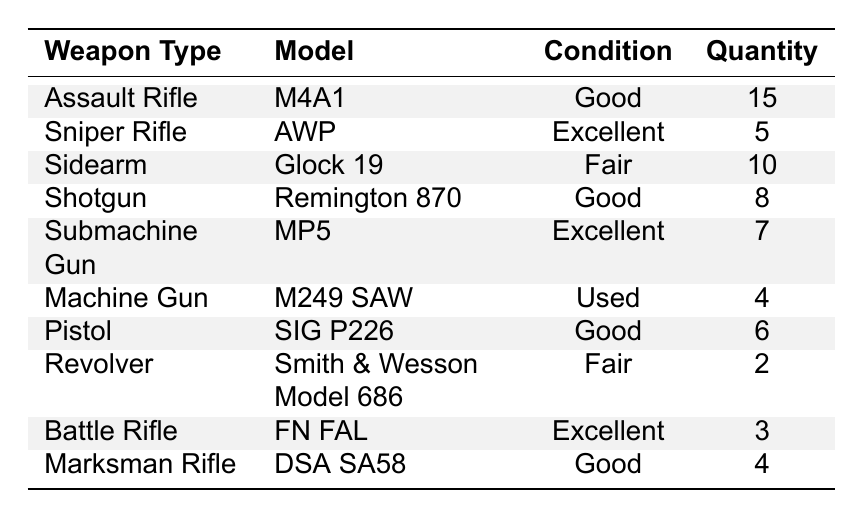What is the total quantity of "Good" condition weapons? To find this, we look at the quantities of weapons listed as "Good": M4A1 (15), Remington 870 (8), SIG P226 (6), and DSA SA58 (4). Summing these values gives us 15 + 8 + 6 + 4 = 33.
Answer: 33 How many types of weapons have an "Excellent" condition? From the table, we see that the weapons listed as "Excellent" are AWP, MP5, and FN FAL. Counting these gives us a total of 3 weapon types.
Answer: 3 Is there a "Used" condition weapon in the inventory? According to the table, there is one weapon with "Used" condition: the M249 SAW. Therefore, the answer is yes.
Answer: Yes What is the difference in quantity between the "Fair" and "Good" condition weapons? For "Fair" condition, we have Glock 19 (10) + Smith & Wesson Model 686 (2) giving us 12 total. For "Good" condition, we had previously summed it to 33. The difference is 33 - 12 = 21.
Answer: 21 Which weapon type has the least quantity and what is that quantity? Looking through the quantities, the least quantity is found with the Smith & Wesson Model 686 at 2 units. This weapon type is a Revolver.
Answer: Revolver, 2 What is the average quantity of "Excellent" condition weapons? The total quantity of "Excellent" weapons is AWP (5), MP5 (7), and FN FAL (3), summing to 5 + 7 + 3 = 15. There are 3 types of "Excellent" weapons, so the average is 15 / 3 = 5.
Answer: 5 How many weapons in total are listed in "Fair" condition? The total for "Fair" condition weapons is Glock 19 (10) + Smith & Wesson Model 686 (2), which gives 10 + 2 = 12.
Answer: 12 What percentage of the total inventory is made up of "Submachine Guns"? First, we must find the total quantity of all weapons, which is 15 + 5 + 10 + 8 + 7 + 4 + 6 + 2 + 3 + 4 = 60. The number of Submachine Guns (MP5) is 7. To find the percentage: (7 / 60) * 100 = 11.67%.
Answer: 11.67% Which weapon type has the highest quantity and what is that quantity? The highest quantity found in the table is for M4A1 under Assault Rifle with 15 units.
Answer: Assault Rifle, 15 What is the condition of the weapon type with the second highest quantity? After identifying the highest quantity (M4A1 - 15), the next highest is Glock 19 with 10 units. Its condition is "Fair".
Answer: Fair 